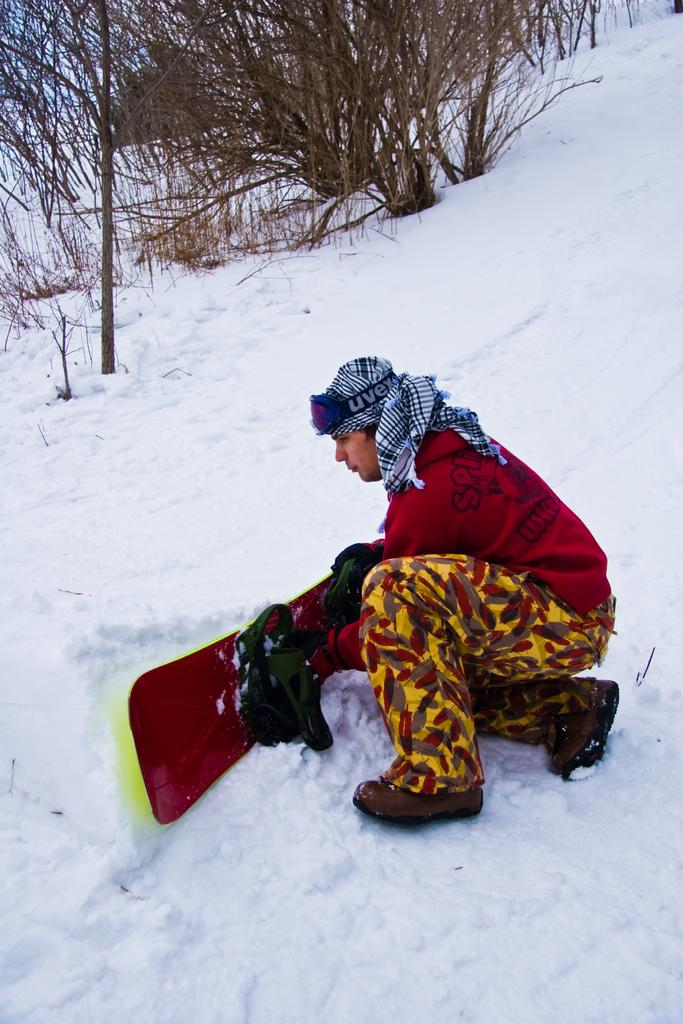Who or what is in the image? There is a person in the image. What is the person holding? The person is holding a snowboard. Where is the person located? The person is on the snow. What can be seen in the background of the image? There are trees in the background of the image. What type of steel is being used to support the person's digestion in the image? There is no steel or mention of digestion in the image; it features a person holding a snowboard on the snow with trees in the background. 